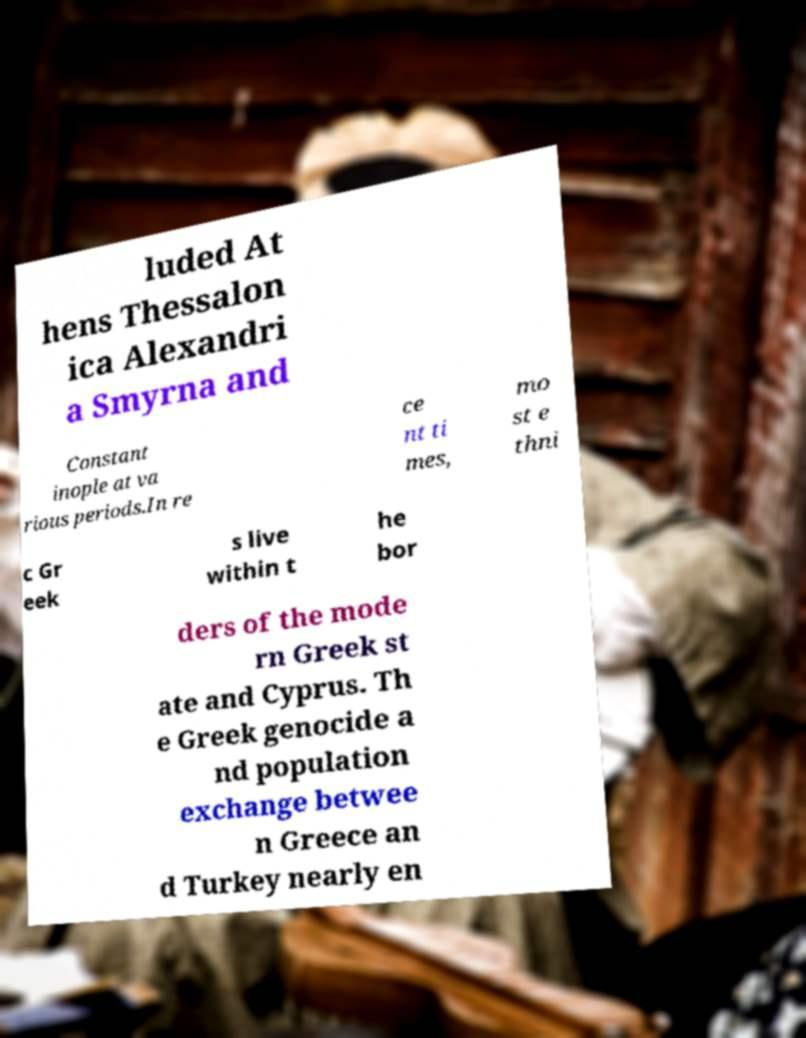There's text embedded in this image that I need extracted. Can you transcribe it verbatim? luded At hens Thessalon ica Alexandri a Smyrna and Constant inople at va rious periods.In re ce nt ti mes, mo st e thni c Gr eek s live within t he bor ders of the mode rn Greek st ate and Cyprus. Th e Greek genocide a nd population exchange betwee n Greece an d Turkey nearly en 